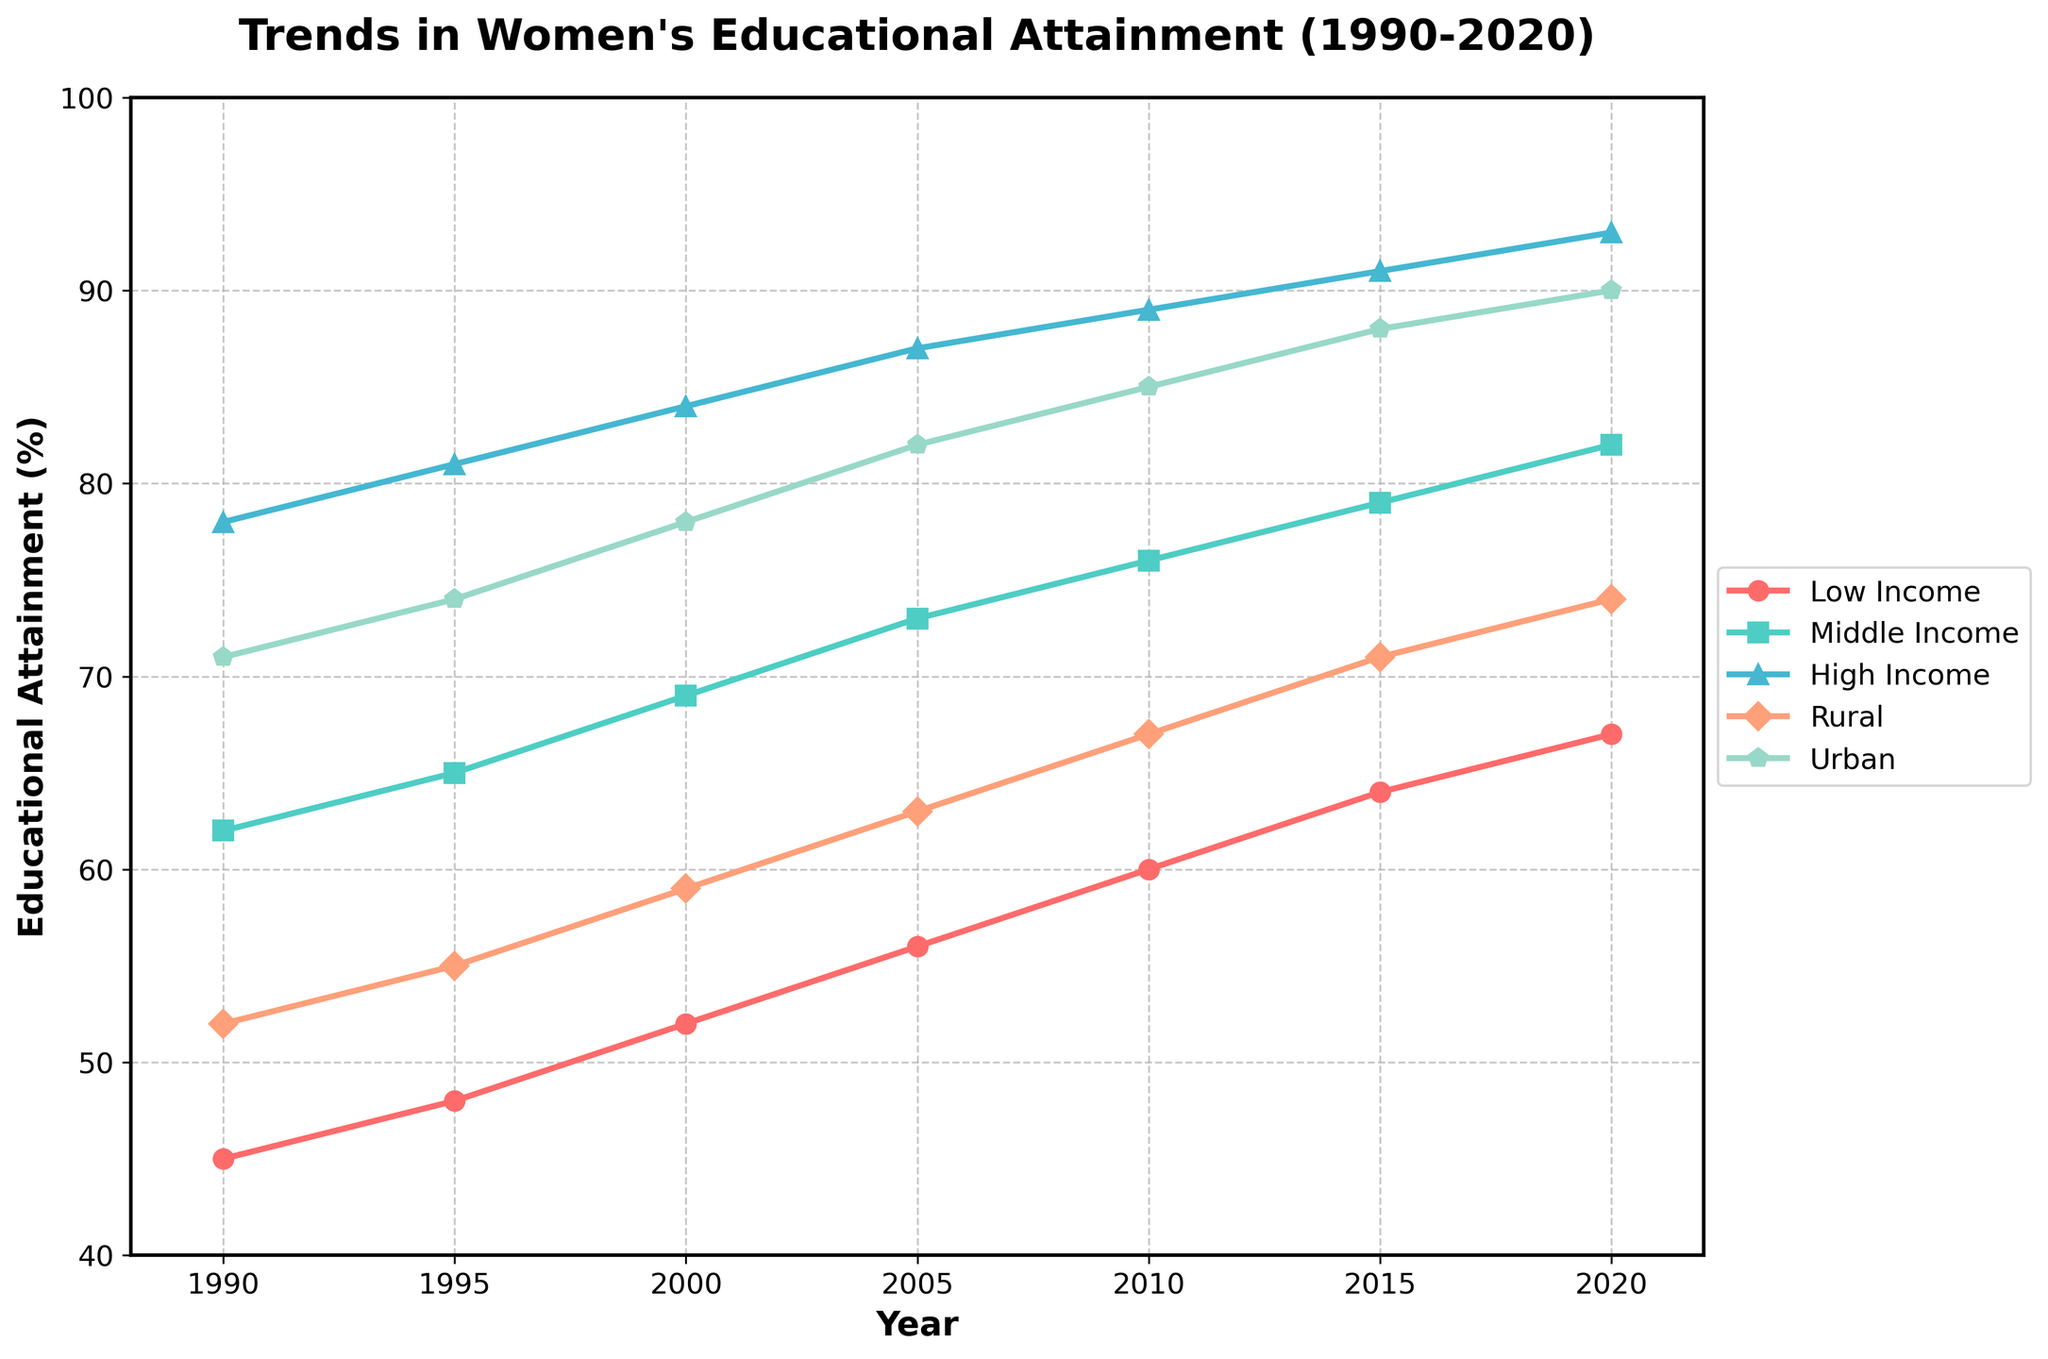What is the trend in educational attainment for low-income women over the 30-year period? From 1990 to 2020, the percentage of educational attainment for low-income women increases steadily. To answer, one can observe that the line representing low-income women consistently rises from 45% in 1990 to 67% in 2020.
Answer: A steady increase from 45% to 67% Which socioeconomic group shows the highest educational attainment in 2020? In the year 2020, the high-income group line reaches the highest percentage, surpassing all other lines at 93%.
Answer: High-income group Compare the percentage increase in educational attainment from 1990 to 2020 for rural and urban women. Which group showed a greater increase? First, observe the starting and ending points for both groups. Rural women start at 52% in 1990 and reach 74% in 2020, an increase of 22 percentage points. Urban women start at 71% in 1990 and reach 90% in 2020, an increase of 19 percentage points. Thus, rural women show a greater increase.
Answer: Rural women Which two socioeconomic groups had the closest educational attainment in the year 2000? Observing the graph for the year 2000, the Middle Income and Urban groups have educational attainment percentages of 69% and 78% respectively, which are relatively close compared to other group pairs.
Answer: Middle Income and Urban groups What is the average educational attainment for middle-income women across all the years shown? The percentages for middle-income women are: 62, 65, 69, 73, 76, 79, and 82. Summing these gives 506. Dividing by the number of data points (7) gives an average of 72.3%.
Answer: 72.3% In which year did high-income women's educational attainment reach 90%? Observing the graph, the line for high-income women crosses the 90% mark between 2015 and 2020.
Answer: Between 2015 and 2020 Compare the educational trend of low-income and high-income groups. Has the gap between their educational attainments widened or narrowed from 1990 to 2020? In 1990, the high-income group's attainment is 78%, and low-income is 45%, a gap of 33 percentage points. By 2020, high-income is at 93% and low-income is at 67%, a gap of 26 percentage points. Therefore, the gap has narrowed.
Answer: The gap has narrowed How does the timeline of educational attainment for urban women compare to that of rural women? The line for urban women consistently stays higher than that for rural women, with both lines showing a general upward trend.
Answer: Urban higher but both increasing Looking at the time period from 2000 to 2010, which group(s) show(s) the smallest increase in educational attainment? Viewing the lines between 2000 and 2010, middle-income women go from 69% to 76%, which is a 7 percentage-point increase. This is smaller than the increases of the other groups during this period.
Answer: Middle Income Which group had a greater increase in educational attainment from 2005 to 2020: Middle Income or Low Income? Middle-income women increased from 73% in 2005 to 82% in 2020, an increase of 9 percentage points. Low-income women increased from 56% in 2005 to 67% in 2020, an increase of 11 percentage points. Thus, Low Income had a greater increase.
Answer: Low Income 